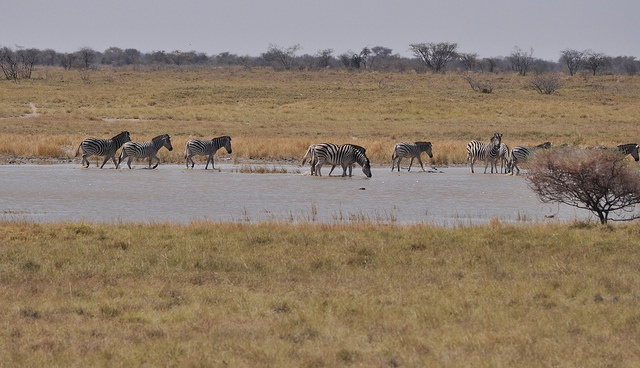Describe the objects in this image and their specific colors. I can see zebra in darkgray, black, and gray tones, zebra in darkgray, gray, and black tones, zebra in darkgray, black, and gray tones, zebra in darkgray, black, and gray tones, and zebra in darkgray, gray, and black tones in this image. 